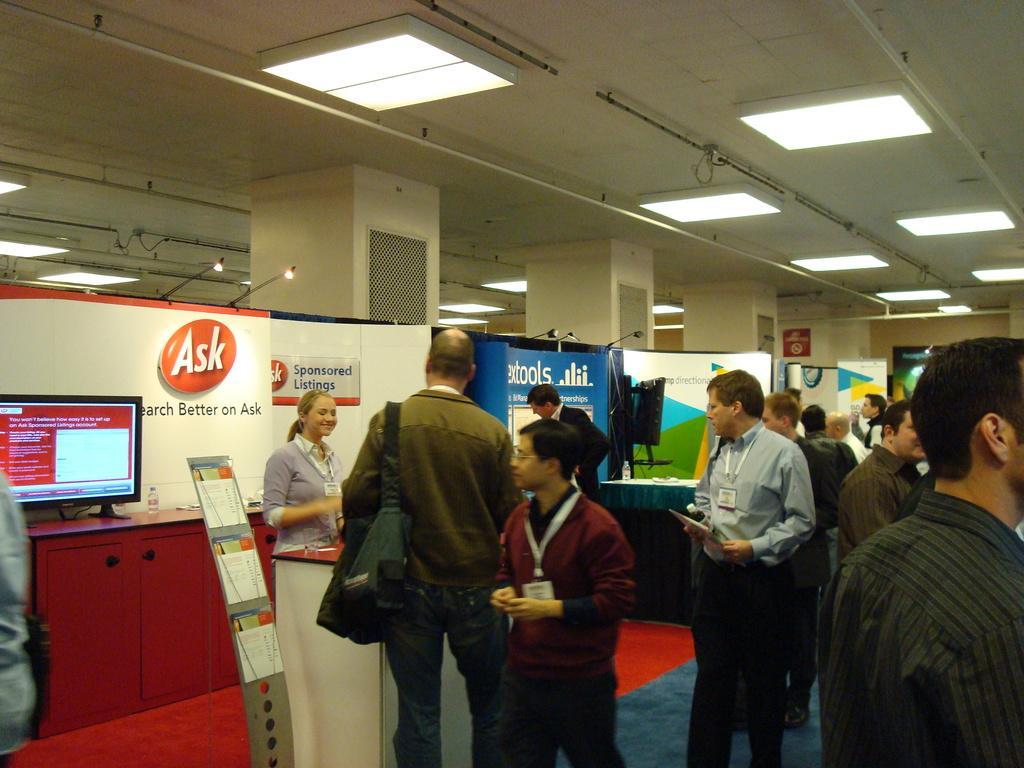Can you describe this image briefly? In this image we can see electric lights, grills, computers, disposal bottles, cupboards and persons on the floor. 